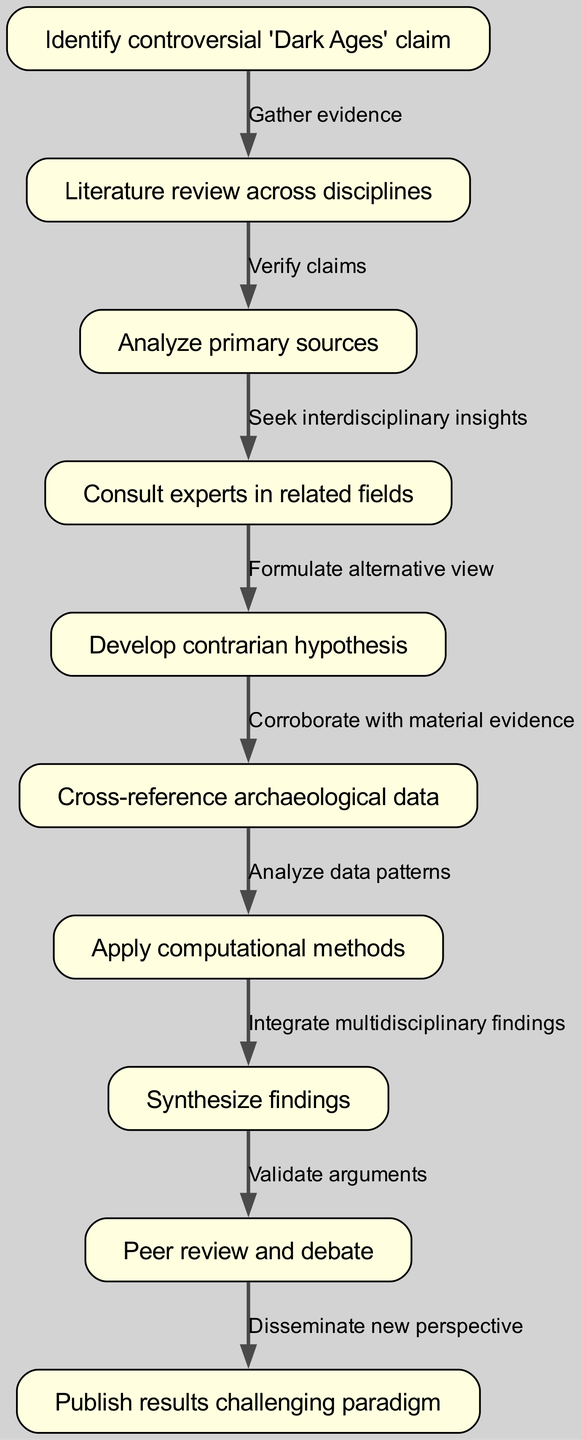What is the first step in the pathway? The first step is represented by node 1, which states "Identify controversial 'Dark Ages' claim". This node is at the top of the diagram and initiates the workflow.
Answer: Identify controversial 'Dark Ages' claim How many nodes are present in the diagram? The diagram contains a total of 10 nodes, as listed in the provided data. Each node represents a distinct step in the interdisciplinary research workflow.
Answer: 10 What connects node 2 and node 3? The edge connecting node 2 ("Literature review across disciplines") to node 3 ("Analyze primary sources") is labeled "Verify claims". This indicates a verification relationship between the two steps.
Answer: Verify claims What is the output of the connection from node 8 to node 9? The flow from node 8 ("Synthesize findings") to node 9 ("Peer review and debate") is labeled "Validate arguments". This shows that the synthesis of findings leads to validation in peer review.
Answer: Validate arguments What type of evidence is corroborated in node 6? Node 6 states "Cross-reference archaeological data", which refers specifically to material evidence used to support claims being analyzed.
Answer: Archaeological data Which node involves the collaboration of multiple experts? Node 4, labeled "Consult experts in related fields," specifically highlights the interdisciplinary collaboration needed to enhance the research process.
Answer: Consult experts in related fields What is the final goal of the pathway? The last step in the pathway, represented by node 10, is labeled "Publish results challenging paradigm", indicating the ultimate aim of disseminating new perspectives based on the research findings.
Answer: Publish results challenging paradigm What is the relationship between node 5 and node 6? The edge connecting node 5 ("Develop contrarian hypothesis") to node 6 ("Cross-reference archaeological data") is labeled "Corroborate with material evidence", indicating that the hypothesis must be supported by physical evidence.
Answer: Corroborate with material evidence What processes must take place after synthesizing findings? After the synthesis of findings in node 8, the next step is peer review and debate, where arguments are validated, making it a crucial part of the research process.
Answer: Peer review and debate 